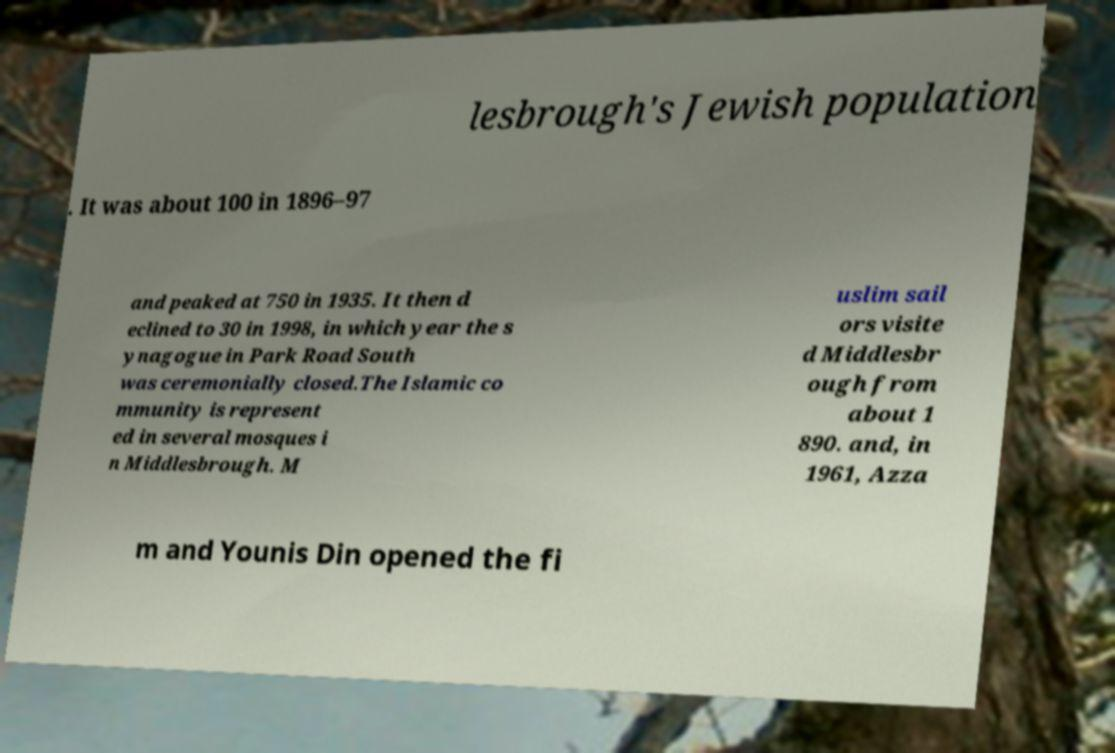Could you extract and type out the text from this image? lesbrough's Jewish population . It was about 100 in 1896–97 and peaked at 750 in 1935. It then d eclined to 30 in 1998, in which year the s ynagogue in Park Road South was ceremonially closed.The Islamic co mmunity is represent ed in several mosques i n Middlesbrough. M uslim sail ors visite d Middlesbr ough from about 1 890. and, in 1961, Azza m and Younis Din opened the fi 